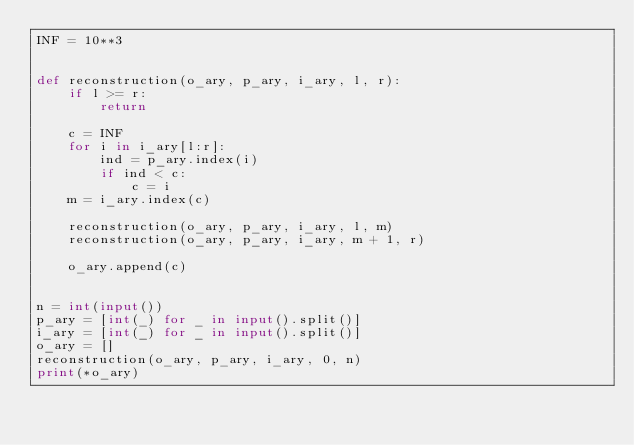<code> <loc_0><loc_0><loc_500><loc_500><_Python_>INF = 10**3


def reconstruction(o_ary, p_ary, i_ary, l, r):
    if l >= r:
        return

    c = INF
    for i in i_ary[l:r]:
        ind = p_ary.index(i)
        if ind < c:
            c = i
    m = i_ary.index(c)

    reconstruction(o_ary, p_ary, i_ary, l, m)
    reconstruction(o_ary, p_ary, i_ary, m + 1, r)

    o_ary.append(c)


n = int(input())
p_ary = [int(_) for _ in input().split()]
i_ary = [int(_) for _ in input().split()]
o_ary = []
reconstruction(o_ary, p_ary, i_ary, 0, n)
print(*o_ary)
</code> 